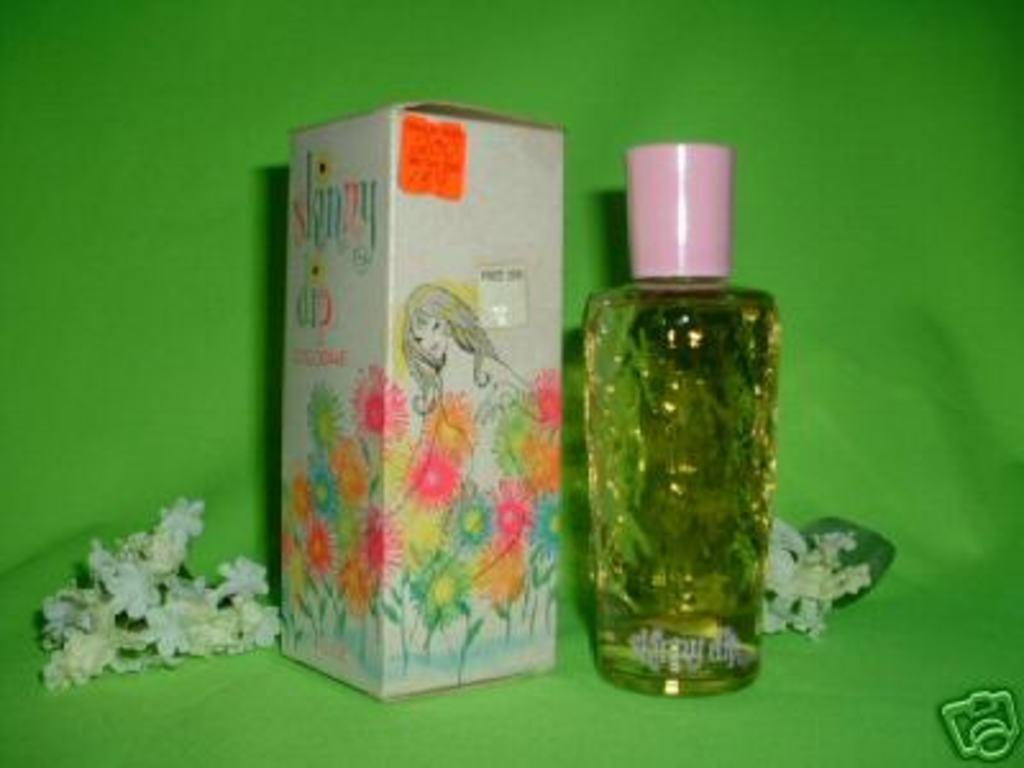<image>
Write a terse but informative summary of the picture. the word skinny is on the box next to the bottle 